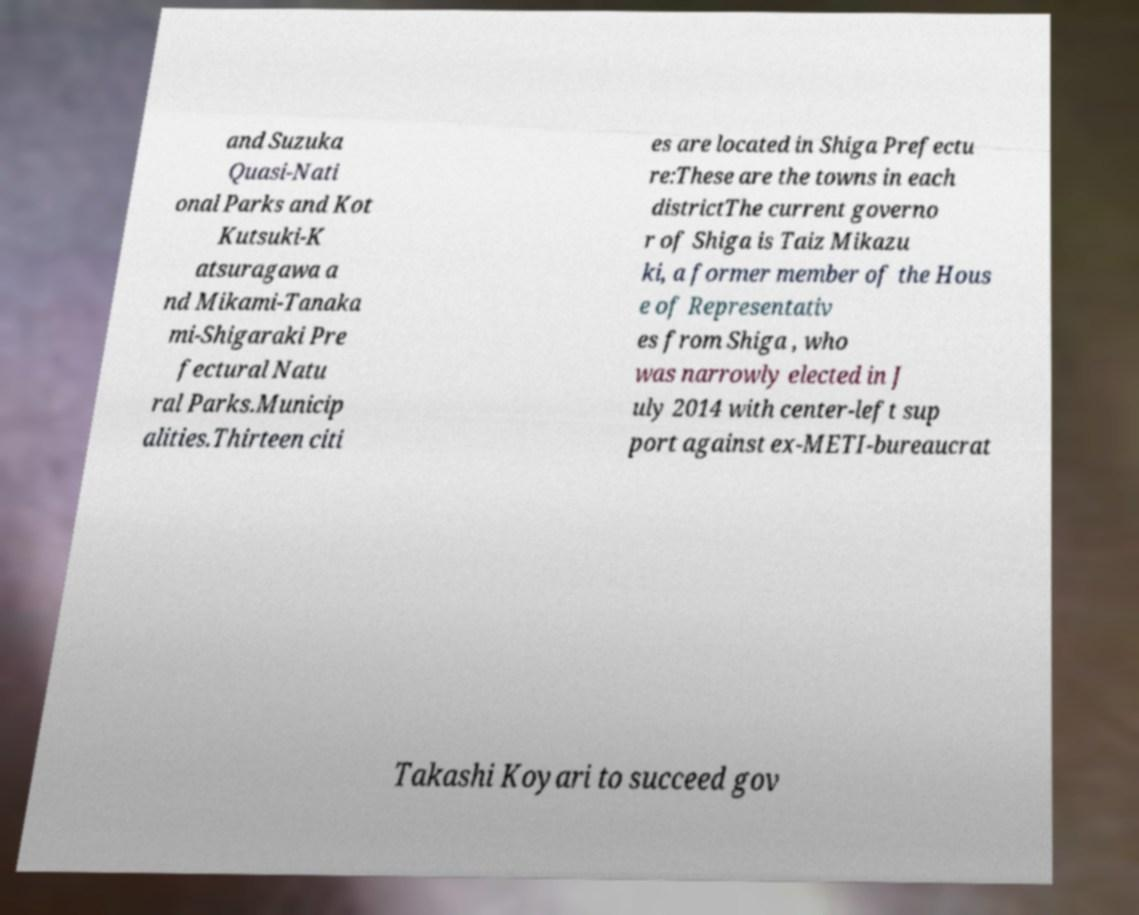I need the written content from this picture converted into text. Can you do that? and Suzuka Quasi-Nati onal Parks and Kot Kutsuki-K atsuragawa a nd Mikami-Tanaka mi-Shigaraki Pre fectural Natu ral Parks.Municip alities.Thirteen citi es are located in Shiga Prefectu re:These are the towns in each districtThe current governo r of Shiga is Taiz Mikazu ki, a former member of the Hous e of Representativ es from Shiga , who was narrowly elected in J uly 2014 with center-left sup port against ex-METI-bureaucrat Takashi Koyari to succeed gov 